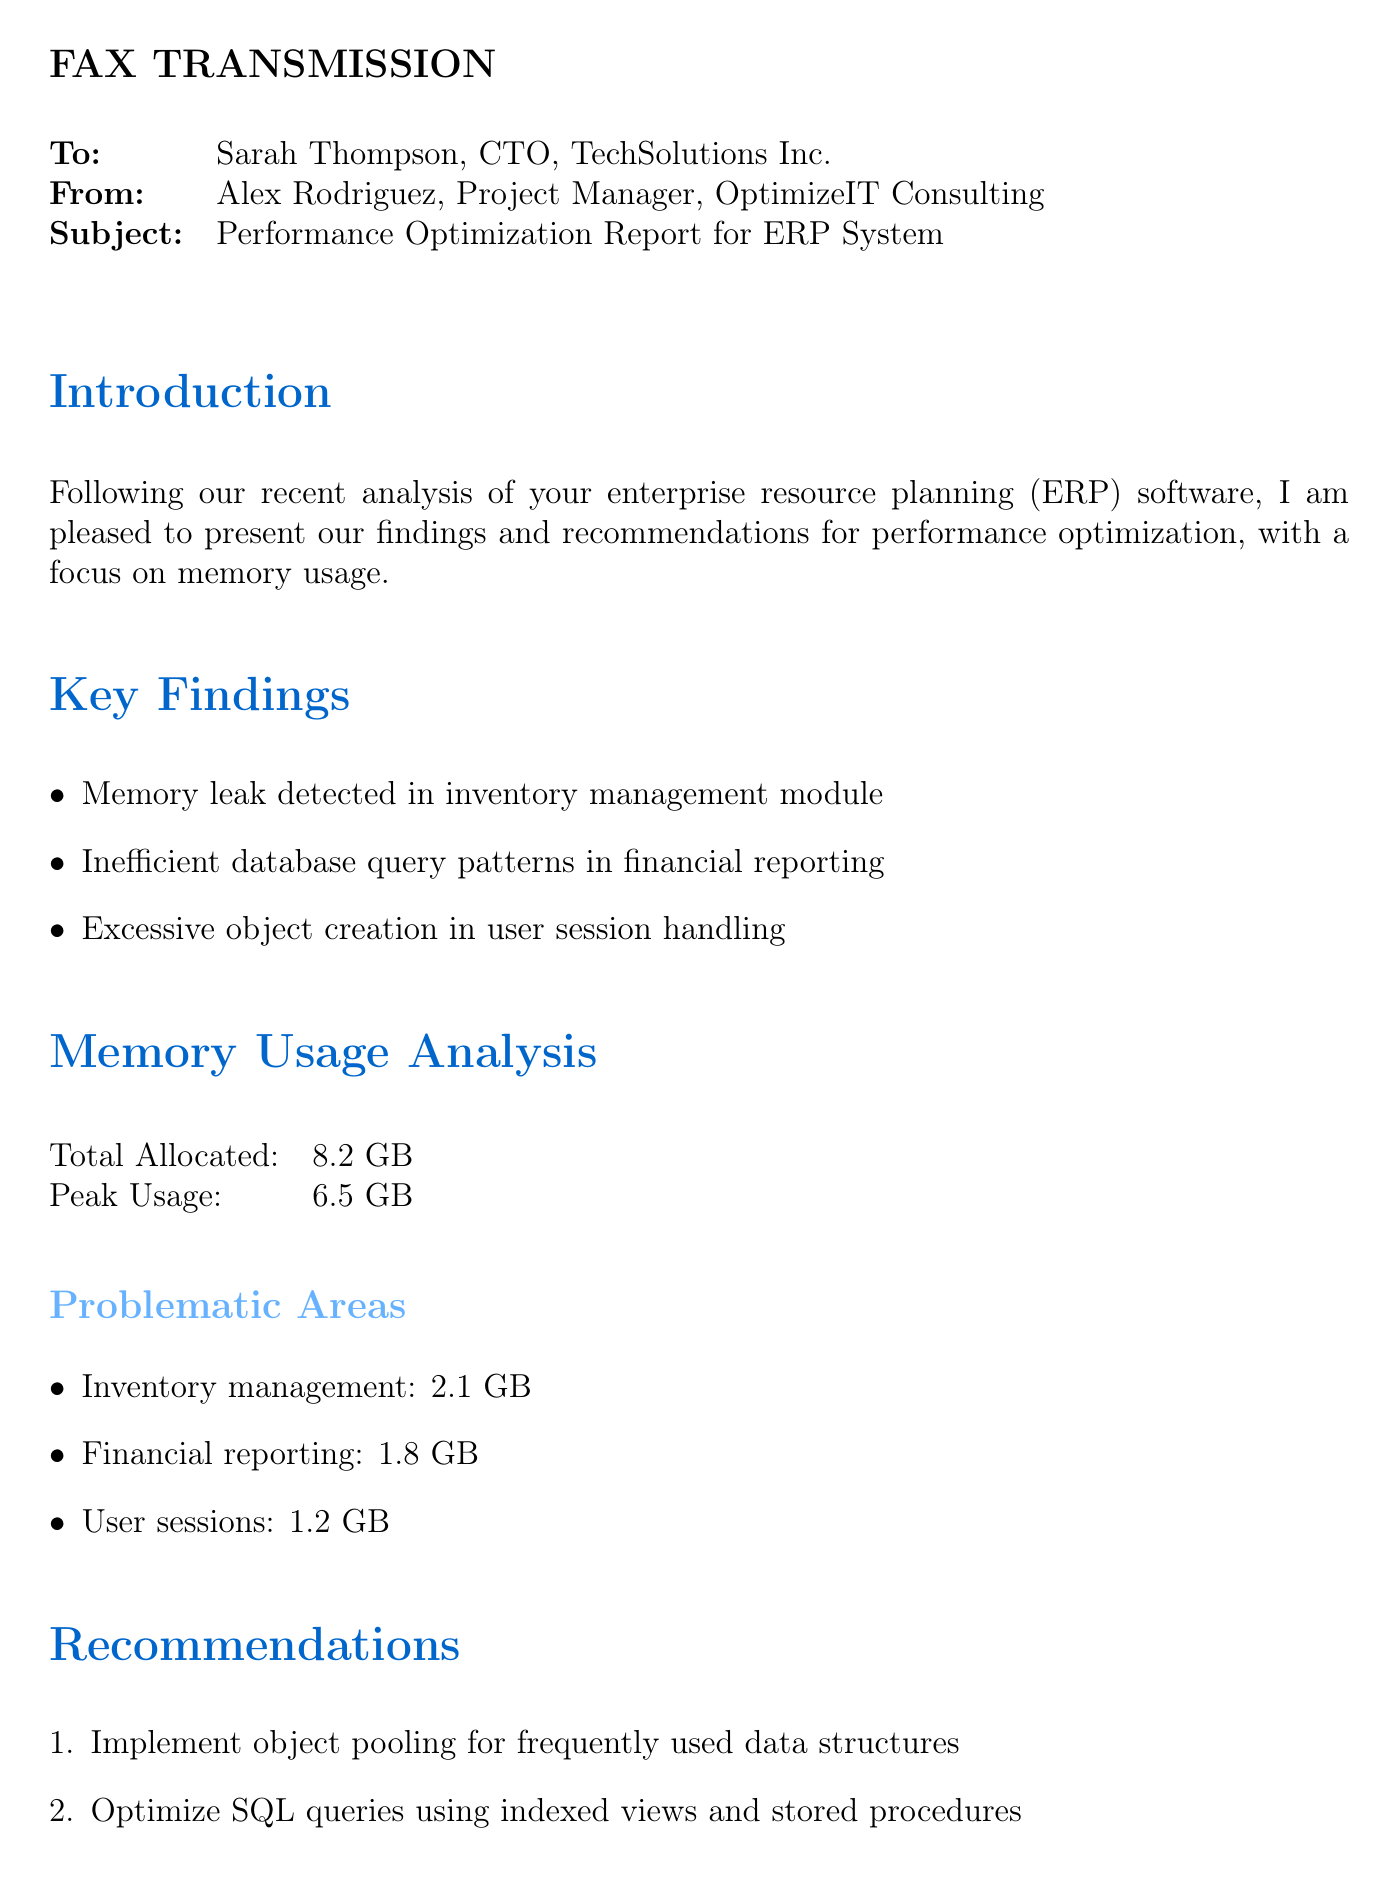What is the subject of the fax? The subject is the main topic addressed in the document, which is the performance optimization report for the ERP system.
Answer: Performance Optimization Report for ERP System Who is the sender of the fax? The sender is the individual or entity that is sending the communication, which is Alex Rodriguez from OptimizeIT Consulting.
Answer: Alex Rodriguez What percentage of memory reduction is expected? This figure indicates the projected decrease in memory usage following recommendations.
Answer: 30-40% What is the peak memory usage reported? This is the maximum amount of memory used during the analysis described in the document.
Answer: 6.5 GB Which module has the highest memory usage? This refers to the specific area of the application that consumes the most memory, as identified in the findings.
Answer: Inventory management What is one of the recommendations provided? This indicates a specific suggestion made in the report to improve performance, taken from the recommendations section.
Answer: Implement object pooling for frequently used data structures What is the expected improvement in response time? This quantifies how much faster the application is anticipated to operate after implementing the recommendations.
Answer: 50% faster What is the title of the document? The title encapsulates the purpose of the fax communication, reflecting the content discussed in the document.
Answer: FAX TRANSMISSION 